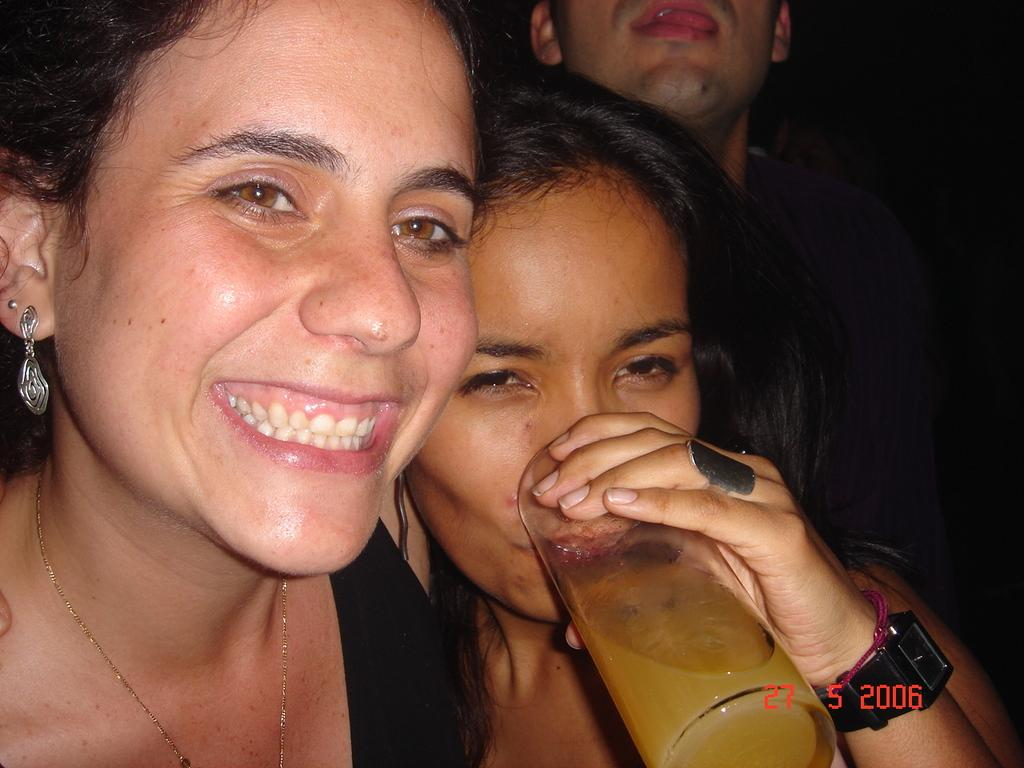How many people are in the image? There is a group of people in the image. What is one person in the group doing? One person in the group is drinking juice. What is the person using to drink the juice? The person is using a glass to drink the juice. What type of behavior does the potato exhibit in the image? There is no potato present in the image, so it cannot exhibit any behavior. 